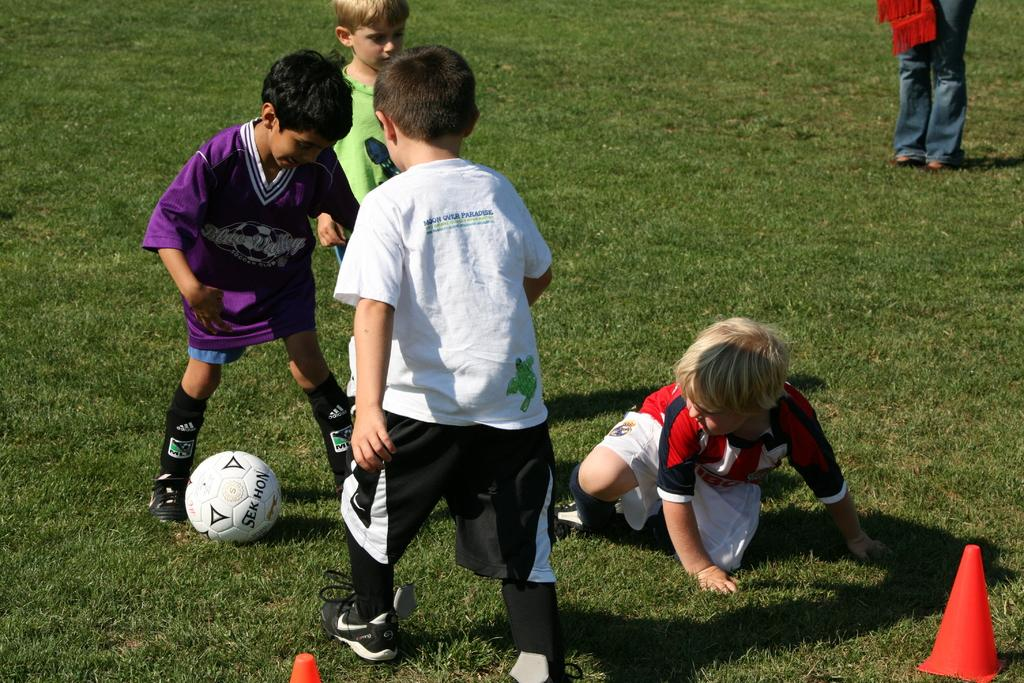What color is the grass in the image? The grass is green. What are the kids doing in the image? The kids are standing on the grass. What object is in front of one of the kids? There is a ball in front of one of the kids. Can you describe another object in the image? There is a red cone in the image. How many chickens are there in the image? There are no chickens present in the image. What type of tooth is visible in the image? There is no tooth visible in the image. 